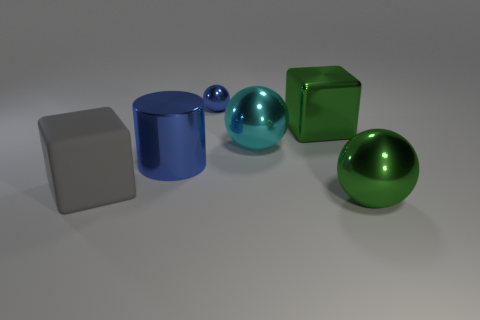Subtract all cyan spheres. How many spheres are left? 2 Add 5 blue things. How many blue things exist? 7 Add 1 tiny spheres. How many objects exist? 7 Subtract all blue balls. How many balls are left? 2 Subtract 0 yellow cylinders. How many objects are left? 6 Subtract all cylinders. How many objects are left? 5 Subtract 1 cylinders. How many cylinders are left? 0 Subtract all purple cylinders. Subtract all blue blocks. How many cylinders are left? 1 Subtract all yellow cylinders. How many green blocks are left? 1 Subtract all rubber blocks. Subtract all big red rubber cylinders. How many objects are left? 5 